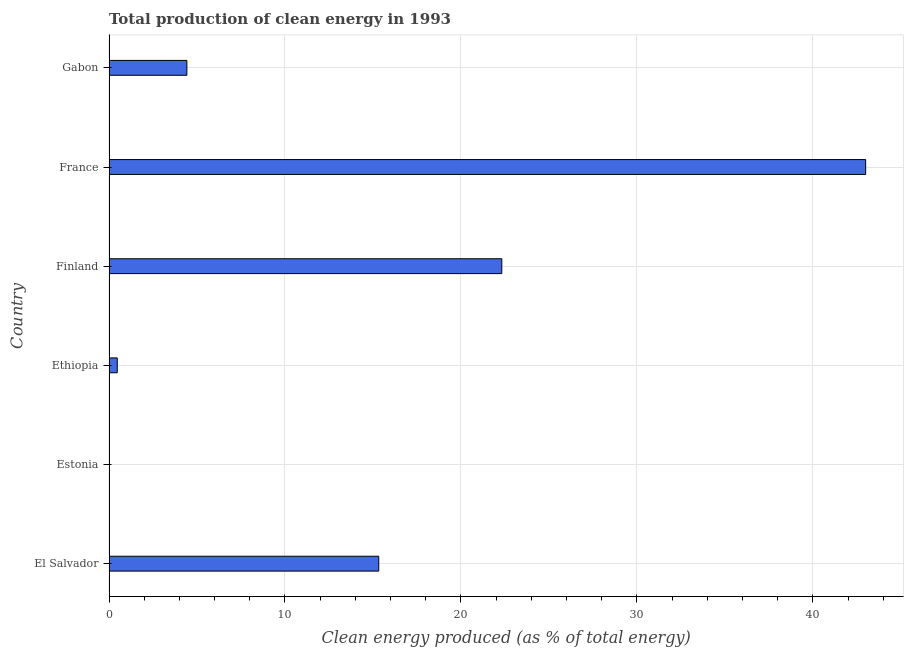Does the graph contain any zero values?
Give a very brief answer. No. Does the graph contain grids?
Offer a terse response. Yes. What is the title of the graph?
Your answer should be compact. Total production of clean energy in 1993. What is the label or title of the X-axis?
Give a very brief answer. Clean energy produced (as % of total energy). What is the label or title of the Y-axis?
Provide a succinct answer. Country. What is the production of clean energy in Finland?
Provide a succinct answer. 22.32. Across all countries, what is the maximum production of clean energy?
Provide a succinct answer. 43. Across all countries, what is the minimum production of clean energy?
Keep it short and to the point. 0. In which country was the production of clean energy minimum?
Make the answer very short. Estonia. What is the sum of the production of clean energy?
Ensure brevity in your answer.  85.55. What is the difference between the production of clean energy in France and Gabon?
Provide a short and direct response. 38.58. What is the average production of clean energy per country?
Ensure brevity in your answer.  14.26. What is the median production of clean energy?
Keep it short and to the point. 9.88. What is the ratio of the production of clean energy in El Salvador to that in Gabon?
Give a very brief answer. 3.46. Is the production of clean energy in Finland less than that in France?
Your answer should be compact. Yes. Is the difference between the production of clean energy in El Salvador and Gabon greater than the difference between any two countries?
Offer a terse response. No. What is the difference between the highest and the second highest production of clean energy?
Make the answer very short. 20.68. Is the sum of the production of clean energy in El Salvador and Estonia greater than the maximum production of clean energy across all countries?
Provide a short and direct response. No. In how many countries, is the production of clean energy greater than the average production of clean energy taken over all countries?
Make the answer very short. 3. Are all the bars in the graph horizontal?
Provide a short and direct response. Yes. How many countries are there in the graph?
Your response must be concise. 6. What is the difference between two consecutive major ticks on the X-axis?
Offer a terse response. 10. Are the values on the major ticks of X-axis written in scientific E-notation?
Offer a very short reply. No. What is the Clean energy produced (as % of total energy) in El Salvador?
Ensure brevity in your answer.  15.33. What is the Clean energy produced (as % of total energy) of Estonia?
Your answer should be very brief. 0. What is the Clean energy produced (as % of total energy) in Ethiopia?
Make the answer very short. 0.47. What is the Clean energy produced (as % of total energy) of Finland?
Keep it short and to the point. 22.32. What is the Clean energy produced (as % of total energy) in France?
Your answer should be very brief. 43. What is the Clean energy produced (as % of total energy) of Gabon?
Your response must be concise. 4.43. What is the difference between the Clean energy produced (as % of total energy) in El Salvador and Estonia?
Your answer should be very brief. 15.33. What is the difference between the Clean energy produced (as % of total energy) in El Salvador and Ethiopia?
Provide a short and direct response. 14.86. What is the difference between the Clean energy produced (as % of total energy) in El Salvador and Finland?
Ensure brevity in your answer.  -6.99. What is the difference between the Clean energy produced (as % of total energy) in El Salvador and France?
Your answer should be compact. -27.67. What is the difference between the Clean energy produced (as % of total energy) in El Salvador and Gabon?
Your answer should be very brief. 10.91. What is the difference between the Clean energy produced (as % of total energy) in Estonia and Ethiopia?
Offer a very short reply. -0.47. What is the difference between the Clean energy produced (as % of total energy) in Estonia and Finland?
Your answer should be very brief. -22.32. What is the difference between the Clean energy produced (as % of total energy) in Estonia and France?
Offer a terse response. -43. What is the difference between the Clean energy produced (as % of total energy) in Estonia and Gabon?
Your response must be concise. -4.42. What is the difference between the Clean energy produced (as % of total energy) in Ethiopia and Finland?
Make the answer very short. -21.85. What is the difference between the Clean energy produced (as % of total energy) in Ethiopia and France?
Your response must be concise. -42.53. What is the difference between the Clean energy produced (as % of total energy) in Ethiopia and Gabon?
Provide a short and direct response. -3.96. What is the difference between the Clean energy produced (as % of total energy) in Finland and France?
Provide a succinct answer. -20.68. What is the difference between the Clean energy produced (as % of total energy) in Finland and Gabon?
Your answer should be compact. 17.9. What is the difference between the Clean energy produced (as % of total energy) in France and Gabon?
Your answer should be very brief. 38.58. What is the ratio of the Clean energy produced (as % of total energy) in El Salvador to that in Estonia?
Provide a short and direct response. 9693. What is the ratio of the Clean energy produced (as % of total energy) in El Salvador to that in Ethiopia?
Ensure brevity in your answer.  32.7. What is the ratio of the Clean energy produced (as % of total energy) in El Salvador to that in Finland?
Make the answer very short. 0.69. What is the ratio of the Clean energy produced (as % of total energy) in El Salvador to that in France?
Ensure brevity in your answer.  0.36. What is the ratio of the Clean energy produced (as % of total energy) in El Salvador to that in Gabon?
Ensure brevity in your answer.  3.46. What is the ratio of the Clean energy produced (as % of total energy) in Estonia to that in Ethiopia?
Provide a succinct answer. 0. What is the ratio of the Clean energy produced (as % of total energy) in Estonia to that in Finland?
Keep it short and to the point. 0. What is the ratio of the Clean energy produced (as % of total energy) in Ethiopia to that in Finland?
Provide a succinct answer. 0.02. What is the ratio of the Clean energy produced (as % of total energy) in Ethiopia to that in France?
Offer a very short reply. 0.01. What is the ratio of the Clean energy produced (as % of total energy) in Ethiopia to that in Gabon?
Your answer should be very brief. 0.11. What is the ratio of the Clean energy produced (as % of total energy) in Finland to that in France?
Keep it short and to the point. 0.52. What is the ratio of the Clean energy produced (as % of total energy) in Finland to that in Gabon?
Your response must be concise. 5.04. What is the ratio of the Clean energy produced (as % of total energy) in France to that in Gabon?
Give a very brief answer. 9.72. 